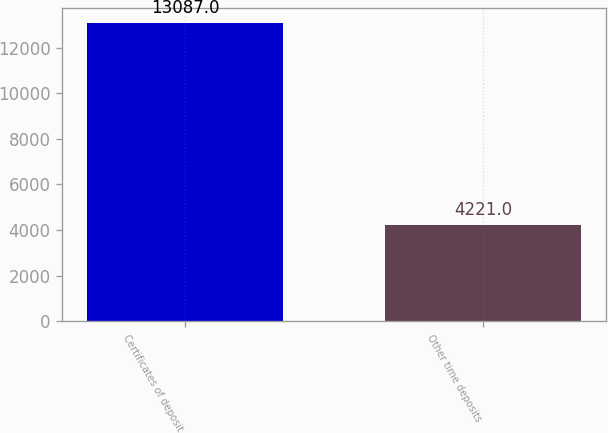<chart> <loc_0><loc_0><loc_500><loc_500><bar_chart><fcel>Certificates of deposit<fcel>Other time deposits<nl><fcel>13087<fcel>4221<nl></chart> 